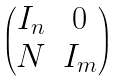<formula> <loc_0><loc_0><loc_500><loc_500>\begin{pmatrix} I _ { n } & 0 \\ N & I _ { m } \end{pmatrix}</formula> 